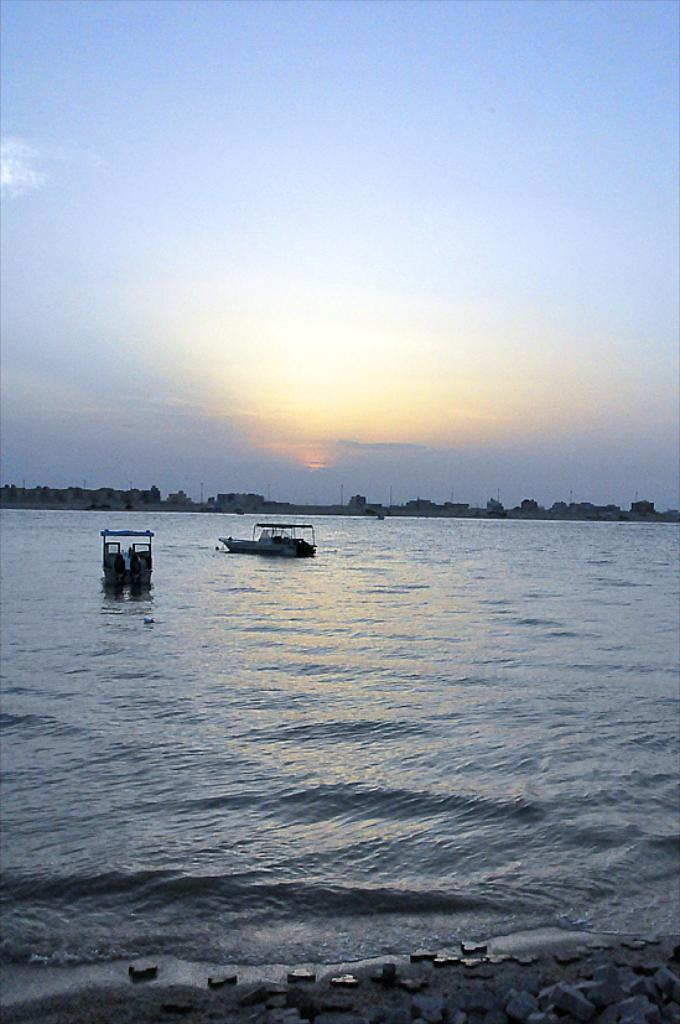What can be seen floating on the water in the image? There are two boats in the water. What is visible in the background of the image? There are buildings visible in the background of the image. What type of rhythm can be heard coming from the boats in the image? There is no indication of any sound or rhythm in the image, as it only features two boats in the water and buildings in the background. 